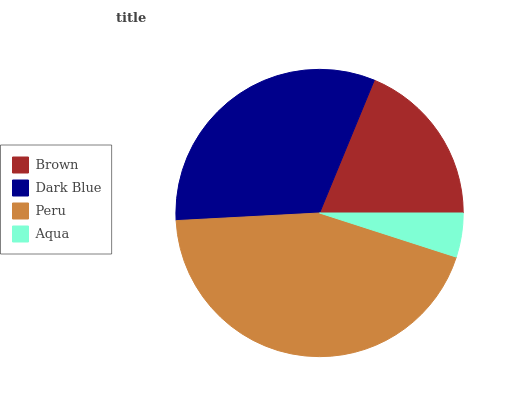Is Aqua the minimum?
Answer yes or no. Yes. Is Peru the maximum?
Answer yes or no. Yes. Is Dark Blue the minimum?
Answer yes or no. No. Is Dark Blue the maximum?
Answer yes or no. No. Is Dark Blue greater than Brown?
Answer yes or no. Yes. Is Brown less than Dark Blue?
Answer yes or no. Yes. Is Brown greater than Dark Blue?
Answer yes or no. No. Is Dark Blue less than Brown?
Answer yes or no. No. Is Dark Blue the high median?
Answer yes or no. Yes. Is Brown the low median?
Answer yes or no. Yes. Is Brown the high median?
Answer yes or no. No. Is Aqua the low median?
Answer yes or no. No. 